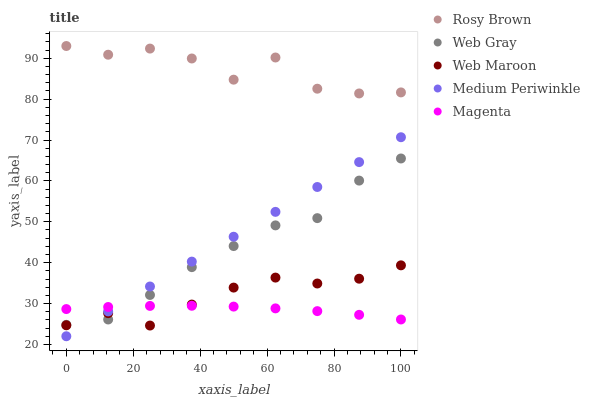Does Magenta have the minimum area under the curve?
Answer yes or no. Yes. Does Rosy Brown have the maximum area under the curve?
Answer yes or no. Yes. Does Rosy Brown have the minimum area under the curve?
Answer yes or no. No. Does Magenta have the maximum area under the curve?
Answer yes or no. No. Is Medium Periwinkle the smoothest?
Answer yes or no. Yes. Is Rosy Brown the roughest?
Answer yes or no. Yes. Is Magenta the smoothest?
Answer yes or no. No. Is Magenta the roughest?
Answer yes or no. No. Does Medium Periwinkle have the lowest value?
Answer yes or no. Yes. Does Magenta have the lowest value?
Answer yes or no. No. Does Rosy Brown have the highest value?
Answer yes or no. Yes. Does Magenta have the highest value?
Answer yes or no. No. Is Medium Periwinkle less than Rosy Brown?
Answer yes or no. Yes. Is Rosy Brown greater than Web Maroon?
Answer yes or no. Yes. Does Medium Periwinkle intersect Magenta?
Answer yes or no. Yes. Is Medium Periwinkle less than Magenta?
Answer yes or no. No. Is Medium Periwinkle greater than Magenta?
Answer yes or no. No. Does Medium Periwinkle intersect Rosy Brown?
Answer yes or no. No. 